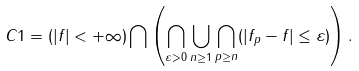Convert formula to latex. <formula><loc_0><loc_0><loc_500><loc_500>C 1 = ( | f | < + \infty ) \bigcap \left ( \bigcap _ { \varepsilon > 0 } \bigcup _ { n \geq 1 } \bigcap _ { p \geq n } ( | f _ { p } - f | \leq \varepsilon ) \right ) .</formula> 